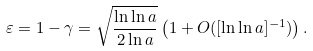<formula> <loc_0><loc_0><loc_500><loc_500>\varepsilon = 1 - \gamma = \sqrt { \frac { \ln \ln a } { 2 \ln a } } \left ( 1 + O ( [ \ln \ln a ] ^ { - 1 } ) \right ) .</formula> 